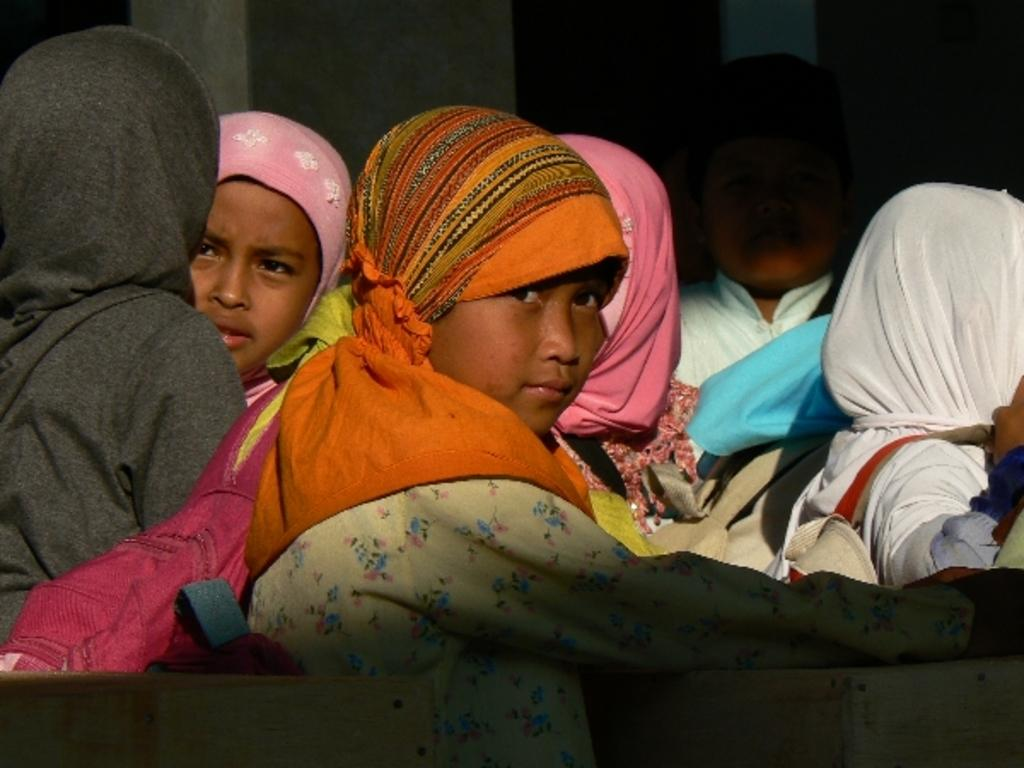Who is present in the image? There are kids in the picture. What are the kids wearing on their heads? The kids are wearing head wear. What can be seen in the background of the image? There is a wall in the background of the picture. How would you describe the lighting in the image? The background of the image is dark. What type of camera can be seen in the hands of the kids in the image? There is no camera visible in the hands of the kids in the image. What kind of metal objects are present in the image? There is no mention of any metal objects in the image. 